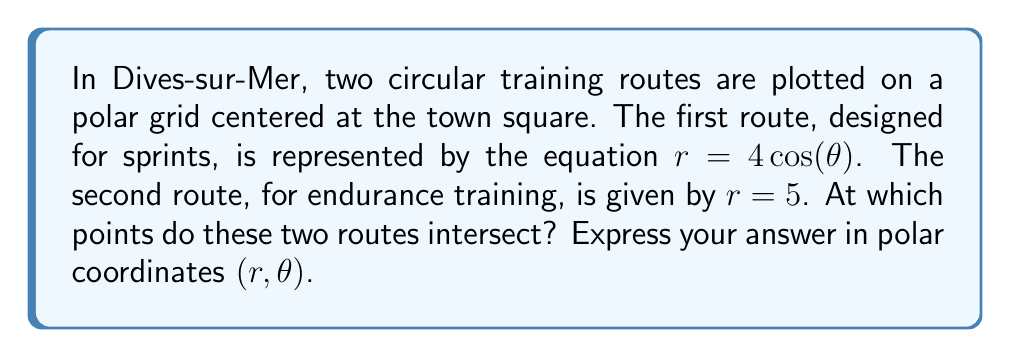Show me your answer to this math problem. To find the intersection points of these two circular routes, we need to solve the system of equations:

$$r = 4\cos(\theta)$$
$$r = 5$$

At the intersection points, both equations must be satisfied. Therefore:

$$4\cos(\theta) = 5$$

Solving for $\theta$:

$$\cos(\theta) = \frac{5}{4}$$

However, this equation has no solution because $\cos(\theta)$ is always between -1 and 1, and $\frac{5}{4}$ is greater than 1.

To visualize this, we can plot the two circles:

[asy]
import graph;
size(200);
real f(real t) {return 4*cos(t);}
draw(polargraph(f,0,pi,operator ..),blue);
draw(polargraph(f,pi,2pi,operator ..),blue+dashed);
draw(Circle((0,0),5),red);
dot((0,0));
label("O",(0,0),SW);
xaxis("x",-6,6,Arrow);
yaxis("y",-6,6,Arrow);
[/asy]

The blue curve represents $r = 4\cos(\theta)$, which is a circle of diameter 8 centered at (2,0). The red circle represents $r = 5$, which is a circle of radius 5 centered at the origin.

As we can see from the graph, these two circles do not intersect. The circle $r = 4\cos(\theta)$ is entirely contained within the circle $r = 5$.
Answer: The two routes do not intersect. There are no intersection points. 